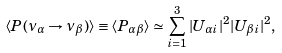<formula> <loc_0><loc_0><loc_500><loc_500>\langle P ( \nu _ { \alpha } \rightarrow \nu _ { \beta } ) \rangle \equiv \langle P _ { \alpha \beta } \rangle \simeq \sum ^ { 3 } _ { i = 1 } | U _ { \alpha i } | ^ { 2 } | U _ { \beta i } | ^ { 2 } ,</formula> 